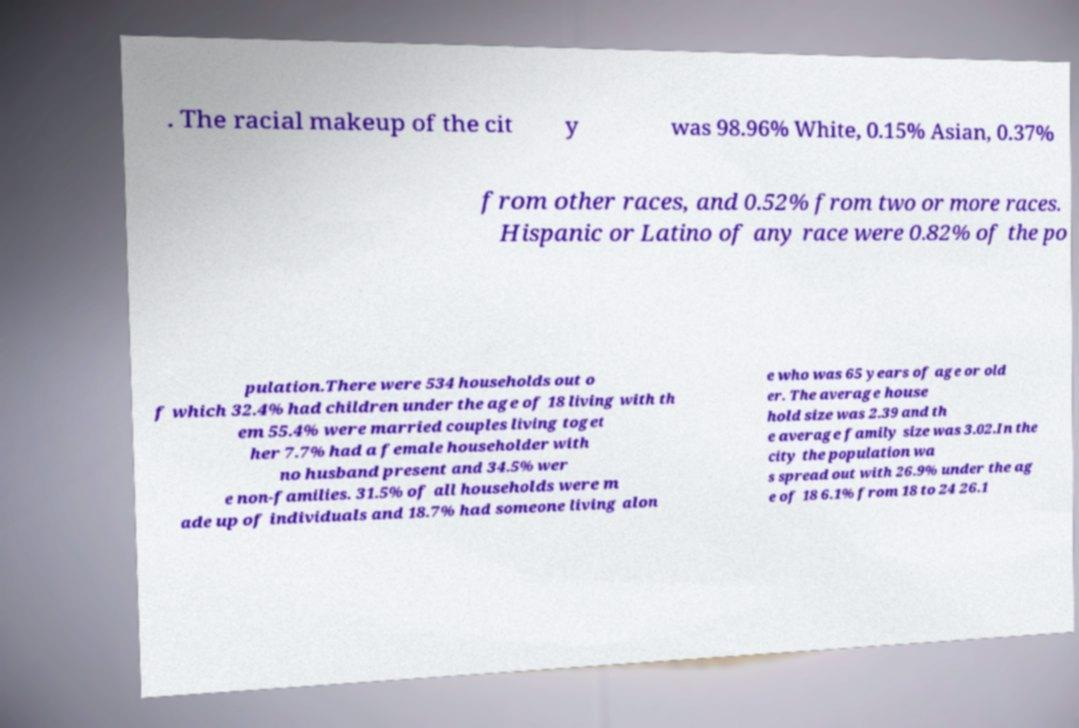For documentation purposes, I need the text within this image transcribed. Could you provide that? . The racial makeup of the cit y was 98.96% White, 0.15% Asian, 0.37% from other races, and 0.52% from two or more races. Hispanic or Latino of any race were 0.82% of the po pulation.There were 534 households out o f which 32.4% had children under the age of 18 living with th em 55.4% were married couples living toget her 7.7% had a female householder with no husband present and 34.5% wer e non-families. 31.5% of all households were m ade up of individuals and 18.7% had someone living alon e who was 65 years of age or old er. The average house hold size was 2.39 and th e average family size was 3.02.In the city the population wa s spread out with 26.9% under the ag e of 18 6.1% from 18 to 24 26.1 